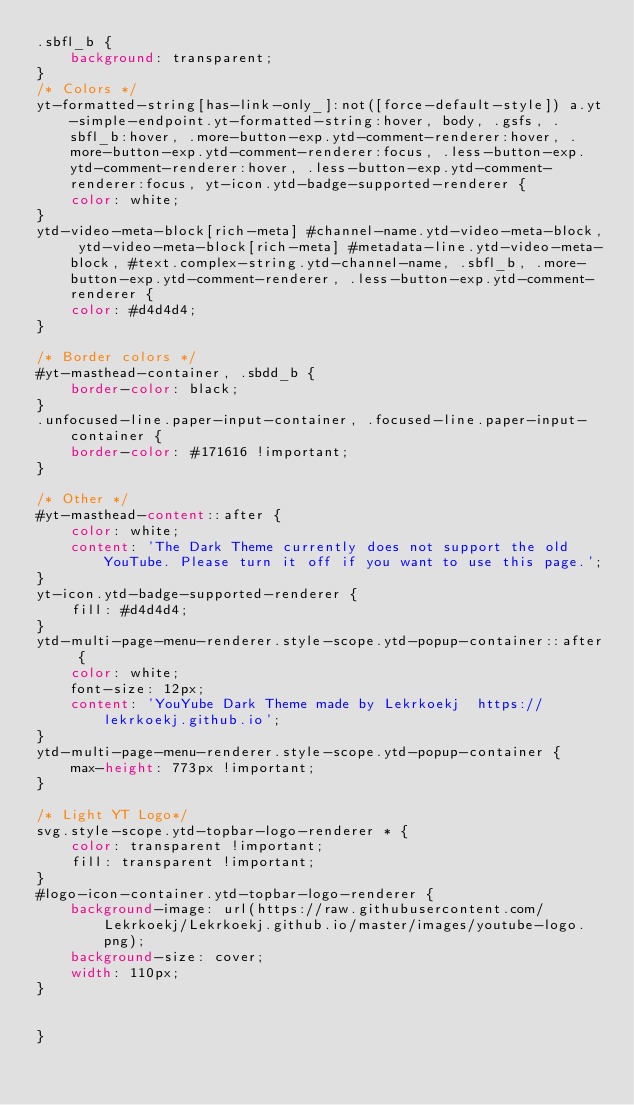<code> <loc_0><loc_0><loc_500><loc_500><_CSS_>.sbfl_b {
    background: transparent;
}
/* Colors */
yt-formatted-string[has-link-only_]:not([force-default-style]) a.yt-simple-endpoint.yt-formatted-string:hover, body, .gsfs, .sbfl_b:hover, .more-button-exp.ytd-comment-renderer:hover, .more-button-exp.ytd-comment-renderer:focus, .less-button-exp.ytd-comment-renderer:hover, .less-button-exp.ytd-comment-renderer:focus, yt-icon.ytd-badge-supported-renderer {
    color: white;
}
ytd-video-meta-block[rich-meta] #channel-name.ytd-video-meta-block, ytd-video-meta-block[rich-meta] #metadata-line.ytd-video-meta-block, #text.complex-string.ytd-channel-name, .sbfl_b, .more-button-exp.ytd-comment-renderer, .less-button-exp.ytd-comment-renderer {
    color: #d4d4d4;
}

/* Border colors */
#yt-masthead-container, .sbdd_b {
    border-color: black;
}
.unfocused-line.paper-input-container, .focused-line.paper-input-container {
    border-color: #171616 !important;
}

/* Other */
#yt-masthead-content::after {
    color: white;
    content: 'The Dark Theme currently does not support the old YouTube. Please turn it off if you want to use this page.';
}
yt-icon.ytd-badge-supported-renderer {
    fill: #d4d4d4;
}
ytd-multi-page-menu-renderer.style-scope.ytd-popup-container::after {
    color: white;
    font-size: 12px;
    content: 'YouYube Dark Theme made by Lekrkoekj  https://lekrkoekj.github.io';
}
ytd-multi-page-menu-renderer.style-scope.ytd-popup-container {
    max-height: 773px !important;
}

/* Light YT Logo*/
svg.style-scope.ytd-topbar-logo-renderer * {
    color: transparent !important;
    fill: transparent !important;
}
#logo-icon-container.ytd-topbar-logo-renderer {
    background-image: url(https://raw.githubusercontent.com/Lekrkoekj/Lekrkoekj.github.io/master/images/youtube-logo.png);
    background-size: cover;
    width: 110px;
}


}</code> 